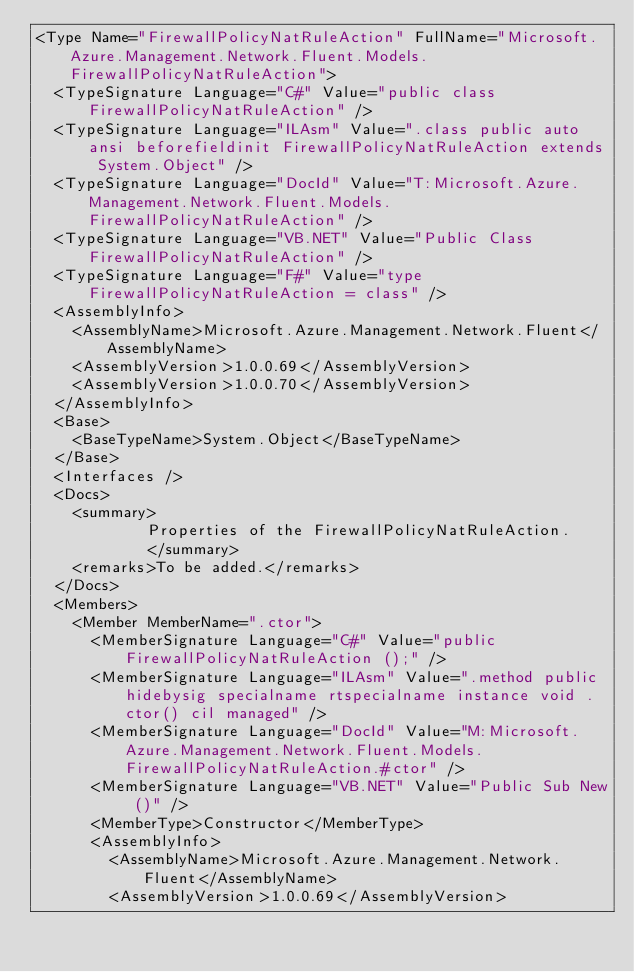<code> <loc_0><loc_0><loc_500><loc_500><_XML_><Type Name="FirewallPolicyNatRuleAction" FullName="Microsoft.Azure.Management.Network.Fluent.Models.FirewallPolicyNatRuleAction">
  <TypeSignature Language="C#" Value="public class FirewallPolicyNatRuleAction" />
  <TypeSignature Language="ILAsm" Value=".class public auto ansi beforefieldinit FirewallPolicyNatRuleAction extends System.Object" />
  <TypeSignature Language="DocId" Value="T:Microsoft.Azure.Management.Network.Fluent.Models.FirewallPolicyNatRuleAction" />
  <TypeSignature Language="VB.NET" Value="Public Class FirewallPolicyNatRuleAction" />
  <TypeSignature Language="F#" Value="type FirewallPolicyNatRuleAction = class" />
  <AssemblyInfo>
    <AssemblyName>Microsoft.Azure.Management.Network.Fluent</AssemblyName>
    <AssemblyVersion>1.0.0.69</AssemblyVersion>
    <AssemblyVersion>1.0.0.70</AssemblyVersion>
  </AssemblyInfo>
  <Base>
    <BaseTypeName>System.Object</BaseTypeName>
  </Base>
  <Interfaces />
  <Docs>
    <summary>
            Properties of the FirewallPolicyNatRuleAction.
            </summary>
    <remarks>To be added.</remarks>
  </Docs>
  <Members>
    <Member MemberName=".ctor">
      <MemberSignature Language="C#" Value="public FirewallPolicyNatRuleAction ();" />
      <MemberSignature Language="ILAsm" Value=".method public hidebysig specialname rtspecialname instance void .ctor() cil managed" />
      <MemberSignature Language="DocId" Value="M:Microsoft.Azure.Management.Network.Fluent.Models.FirewallPolicyNatRuleAction.#ctor" />
      <MemberSignature Language="VB.NET" Value="Public Sub New ()" />
      <MemberType>Constructor</MemberType>
      <AssemblyInfo>
        <AssemblyName>Microsoft.Azure.Management.Network.Fluent</AssemblyName>
        <AssemblyVersion>1.0.0.69</AssemblyVersion></code> 